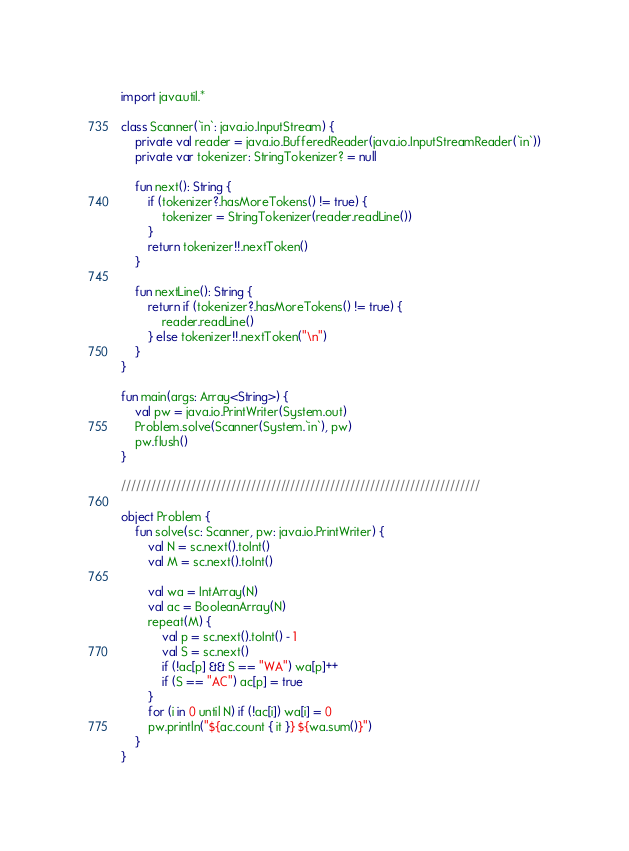Convert code to text. <code><loc_0><loc_0><loc_500><loc_500><_Kotlin_>import java.util.*

class Scanner(`in`: java.io.InputStream) {
    private val reader = java.io.BufferedReader(java.io.InputStreamReader(`in`))
    private var tokenizer: StringTokenizer? = null

    fun next(): String {
        if (tokenizer?.hasMoreTokens() != true) {
            tokenizer = StringTokenizer(reader.readLine())
        }
        return tokenizer!!.nextToken()
    }

    fun nextLine(): String {
        return if (tokenizer?.hasMoreTokens() != true) {
            reader.readLine()
        } else tokenizer!!.nextToken("\n")
    }
}

fun main(args: Array<String>) {
    val pw = java.io.PrintWriter(System.out)
    Problem.solve(Scanner(System.`in`), pw)
    pw.flush()
}

////////////////////////////////////////////////////////////////////////

object Problem {
    fun solve(sc: Scanner, pw: java.io.PrintWriter) {
        val N = sc.next().toInt()
        val M = sc.next().toInt()

        val wa = IntArray(N)
        val ac = BooleanArray(N)
        repeat(M) {
            val p = sc.next().toInt() - 1
            val S = sc.next()
            if (!ac[p] && S == "WA") wa[p]++
            if (S == "AC") ac[p] = true
        }
        for (i in 0 until N) if (!ac[i]) wa[i] = 0
        pw.println("${ac.count { it }} ${wa.sum()}")
    }
}
</code> 